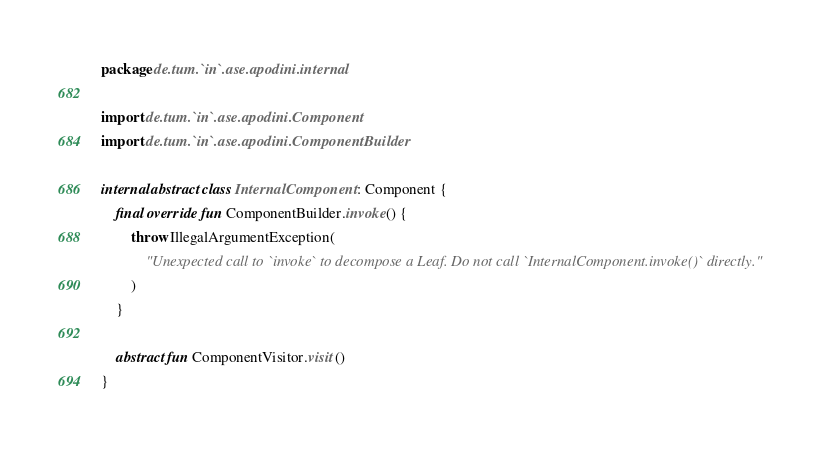Convert code to text. <code><loc_0><loc_0><loc_500><loc_500><_Kotlin_>package de.tum.`in`.ase.apodini.internal

import de.tum.`in`.ase.apodini.Component
import de.tum.`in`.ase.apodini.ComponentBuilder

internal abstract class InternalComponent : Component {
    final override fun ComponentBuilder.invoke() {
        throw IllegalArgumentException(
            "Unexpected call to `invoke` to decompose a Leaf. Do not call `InternalComponent.invoke()` directly."
        )
    }

    abstract fun ComponentVisitor.visit()
}</code> 